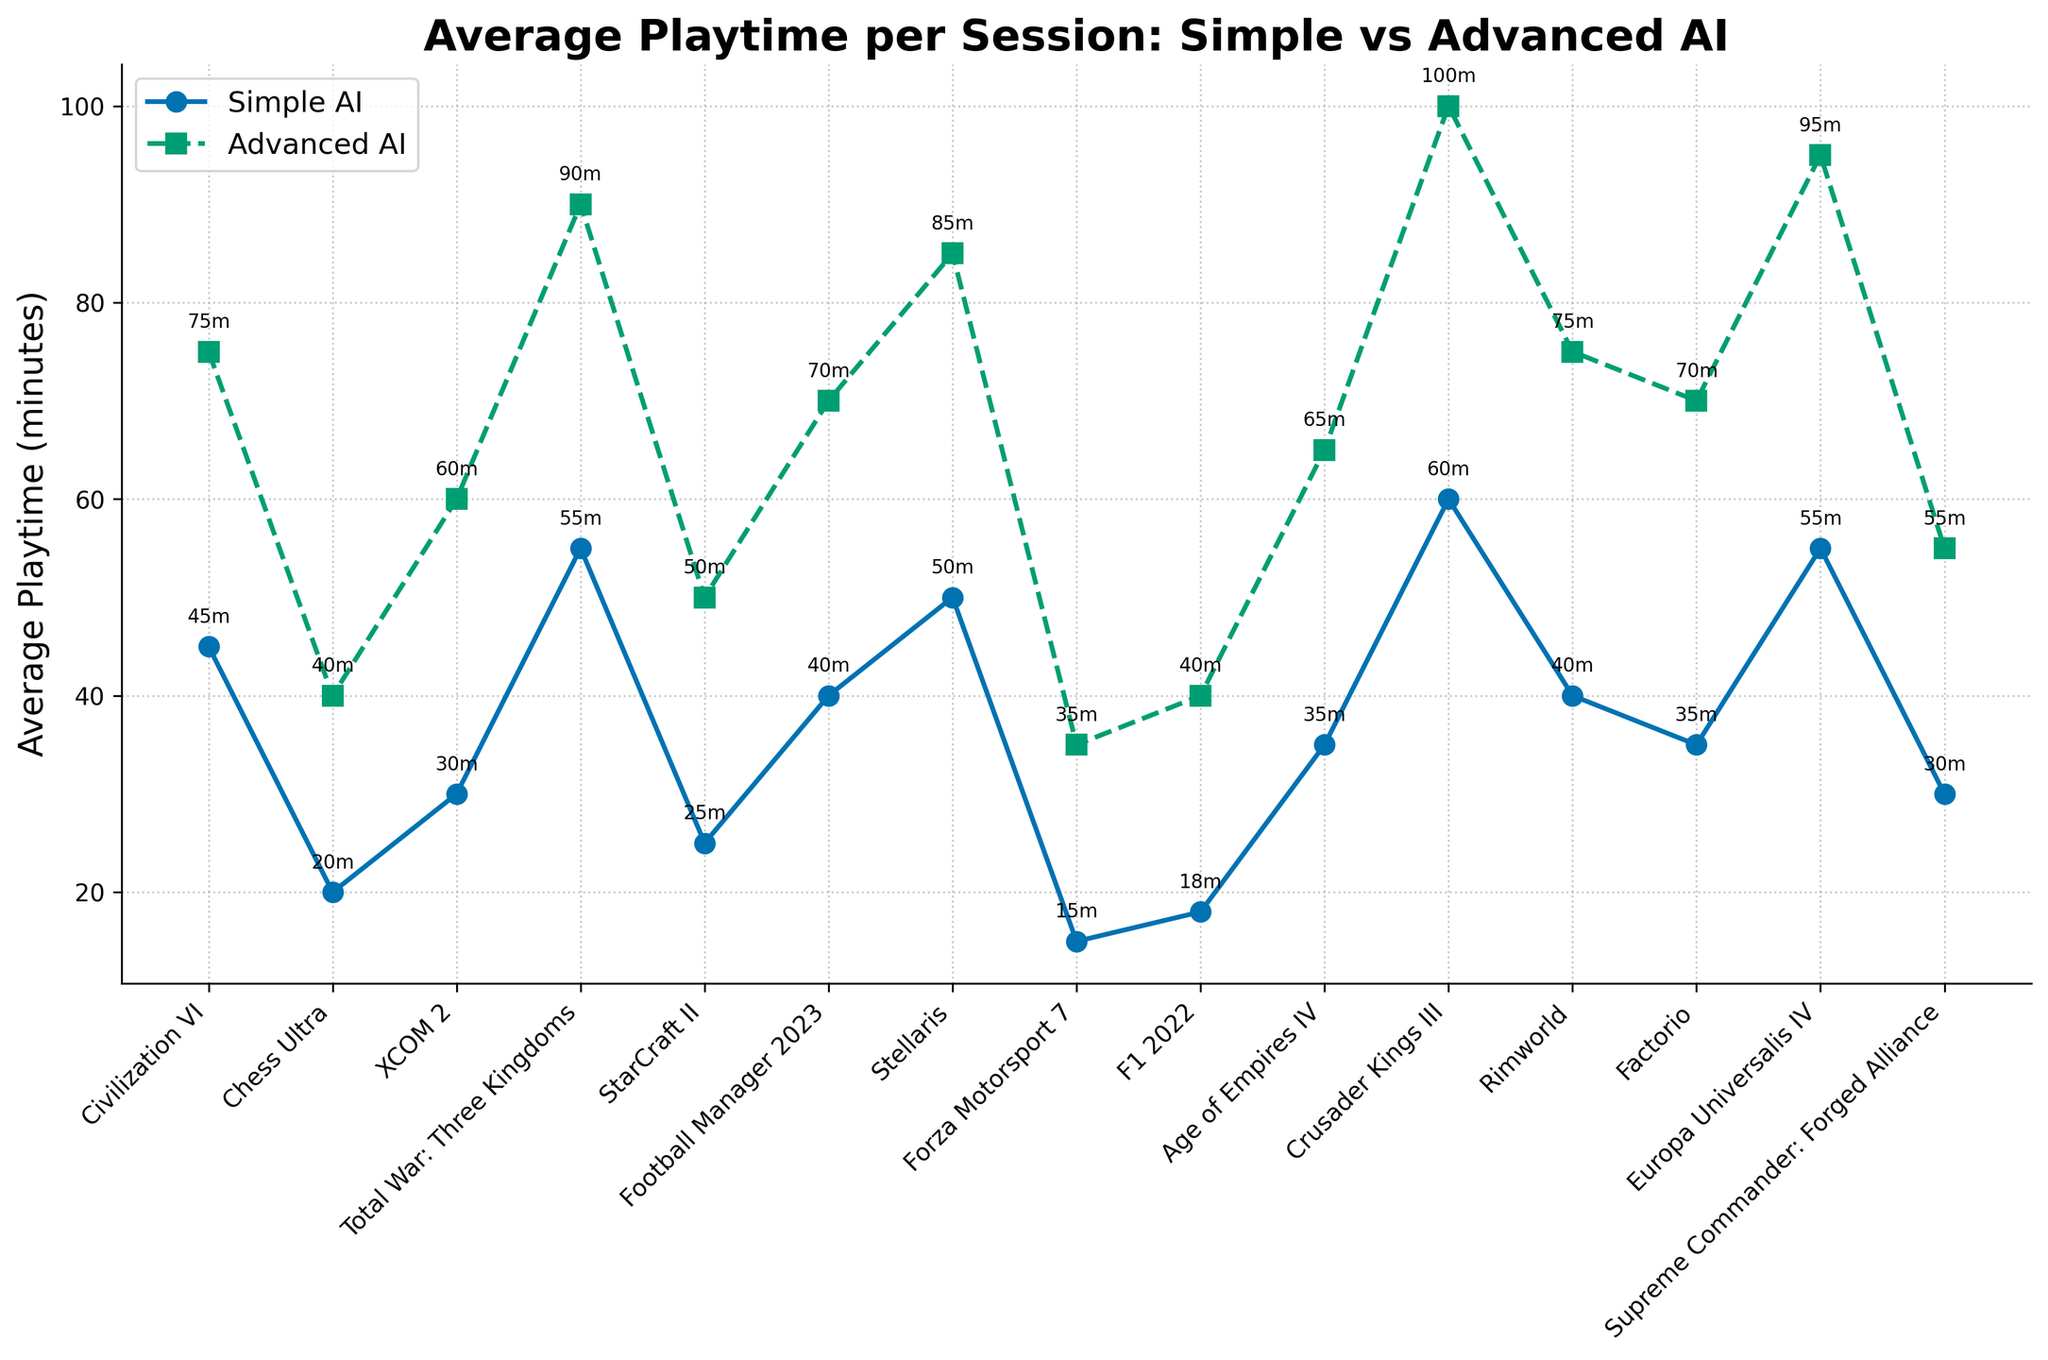Which game shows the largest difference in average playtime between Simple and Advanced AI? To find the game with the largest difference, look for the game with the highest absolute difference between the two playtimes. The game "Crusader Kings III" has playtimes of 60 and 100 minutes for Simple and Advanced AI, respectively, resulting in a difference of 40 minutes.
Answer: Crusader Kings III How much longer is the average playtime for Advanced AI compared to Simple AI for "Total War: Three Kingdoms"? Subtract the average playtime of Simple AI from the average playtime of Advanced AI for "Total War: Three Kingdoms". This is 90 minutes (Advanced AI) minus 55 minutes (Simple AI).
Answer: 35 minutes What is the average playtime across all games for Advanced AI? Sum all playtimes for Advanced AI and divide by the number of games. The sum is 75+40+60+90+50+70+85+35+40+65+100+75+70+95+55 = 1005; there are 15 games, so the average is 1005/15.
Answer: 67 minutes Which game has the smallest increase in playtime from Simple AI to Advanced AI? Identify the game with the smallest difference between Simple and Advanced AI playtimes. "Chess Ultra" has playtimes of 20 and 40 minutes, resulting in a smallest difference of 20 minutes.
Answer: Chess Ultra Are there any games where the average playtime with Advanced AI is less than double the playtime with Simple AI? If yes, name one. To find such games, compare the playtime of Advanced AI to twice the playtime of Simple AI (2x Simple AI). For instance, "Chess Ultra" with 20 minutes (Simple AI) and 40 minutes (Advanced AI) fits this criterion.
Answer: Chess Ultra Comparing the games "Europa Universalis IV" and "Rimworld", which game has a higher playtime increase when switching from Simple AI to Advanced AI? Calculate the difference between Advanced and Simple AI playtimes for both games. "Europa Universalis IV" has a difference of 95 - 55 = 40 minutes, while "Rimworld" has a difference of 75 - 40 = 35 minutes.
Answer: Europa Universalis IV What is the total average playtime for "XCOM 2" considering both Simple and Advanced AI? Add the playtimes for both AI levels for the game "XCOM 2". This is 30 (Simple AI) + 60 (Advanced AI).
Answer: 90 minutes How does the playtime for Advanced AI in "Football Manager 2023" compare to the playtime for Simple AI in "Crusader Kings III"? Compare 70 minutes (Advanced AI in "Football Manager 2023") to 60 minutes (Simple AI in "Crusader Kings III").
Answer: Longer Which game with Advanced AI has the longest average playtime? Find the game with the highest playtime value under Advanced AI. "Crusader Kings III" has an Advanced AI playtime of 100 minutes, the longest among all the games listed.
Answer: Crusader Kings III 